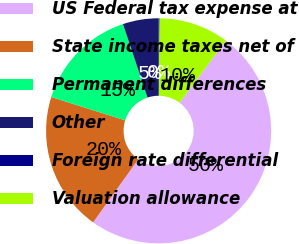Convert chart. <chart><loc_0><loc_0><loc_500><loc_500><pie_chart><fcel>US Federal tax expense at<fcel>State income taxes net of<fcel>Permanent differences<fcel>Other<fcel>Foreign rate differential<fcel>Valuation allowance<nl><fcel>49.69%<fcel>19.97%<fcel>15.02%<fcel>5.11%<fcel>0.16%<fcel>10.06%<nl></chart> 